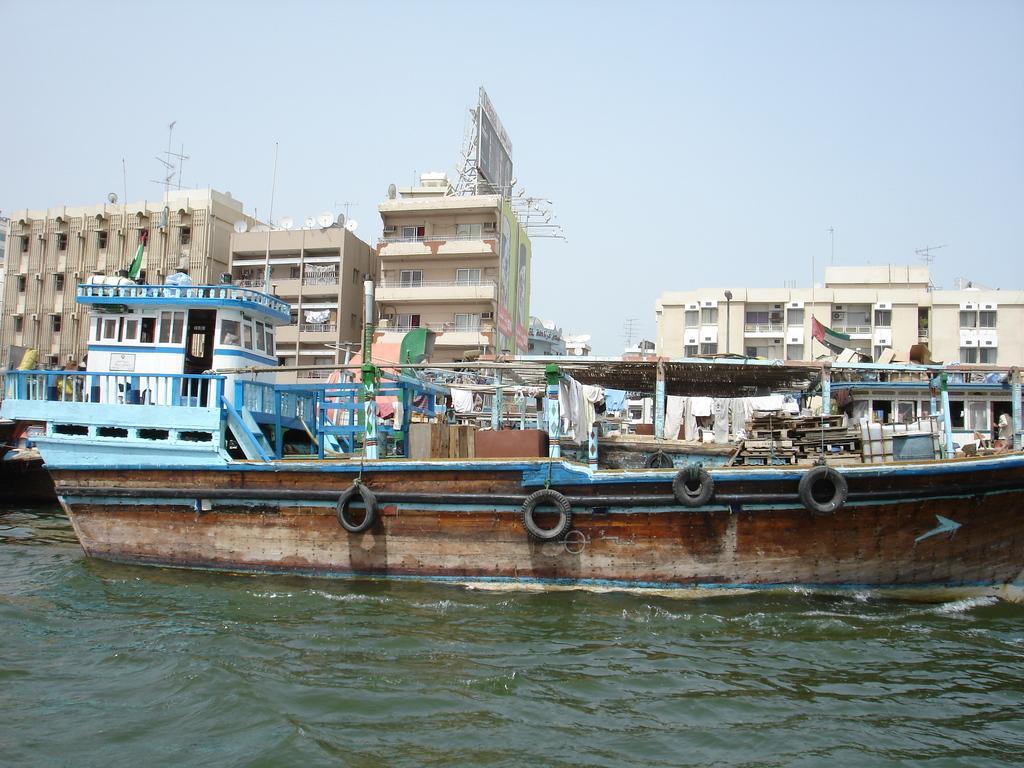Describe this image in one or two sentences. In the foreground I can see boats in the water, fence, shed, houses, buildings, crowd, flag poles and pillars. In the background I can see the sky. This image is taken may be near the ocean. 